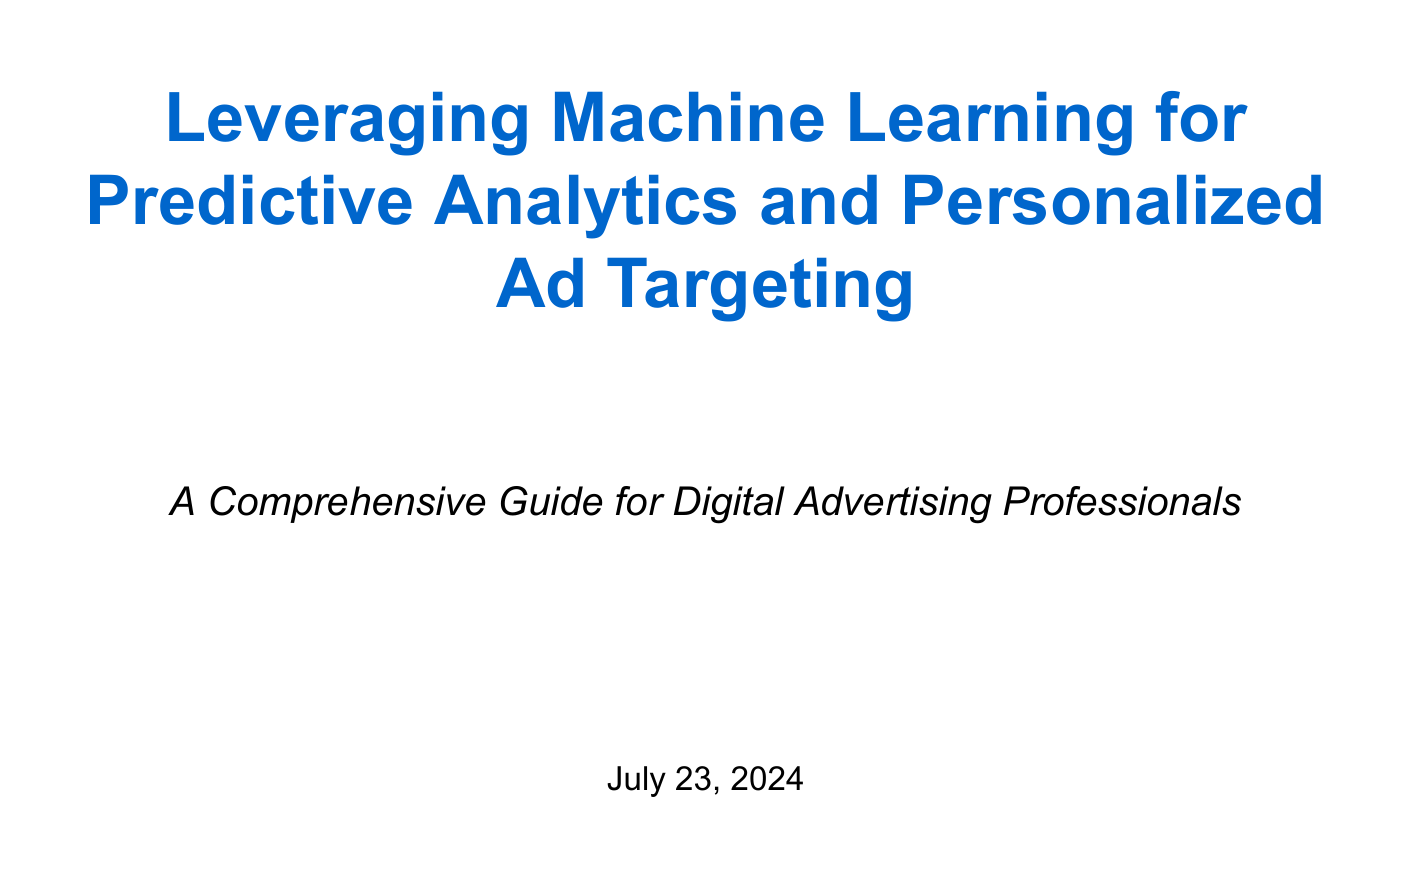What is the title of the manual? The title of the manual is provided at the top of the document.
Answer: Leveraging Machine Learning for Predictive Analytics and Personalized Ad Targeting How many main sections are in the document? The document contains a list of main sections outlined in the table of contents.
Answer: Nine What is one key benefit of machine learning for ad platforms? The document discusses several benefits, particularly noted in the introduction.
Answer: Informed decision-making Name a popular ML algorithm used in advertising. The overview of algorithms in the introduction lists various options.
Answer: Decision trees What type of data is relevant for ad targeting? The types of data are listed in the data collection section.
Answer: User behavior data Which strategy uses collaborative filtering? The personalized ad targeting strategies outline specific methodologies.
Answer: Product recommendations What is one ethical consideration mentioned in the document? The document outlines ethical considerations regarding machine learning in advertising.
Answer: Addressing bias How does the document suggest improving performance in ML-driven campaigns? The measuring and optimizing performance section describes methods for assessment and improvement.
Answer: Continuous learning Which platform is mentioned for model deployment? The implementing ML models in ad platforms section lists various platforms.
Answer: Amazon SageMaker What does Appendix A provide? The appendix sections detail the contents they cover, with Appendix A specifically focusing on certain resources.
Answer: Sample code snippets 